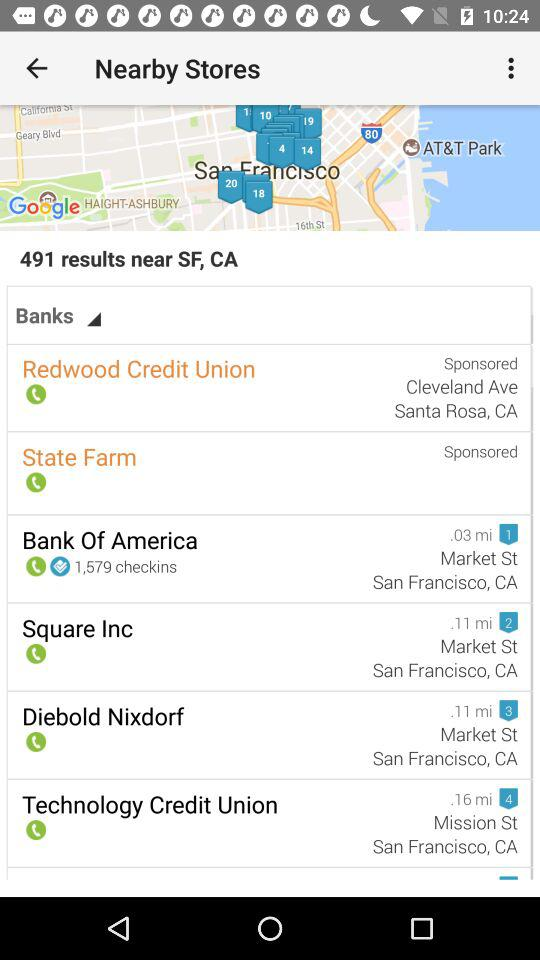What is the address of Square Inc? Square Inc's address is Market St., San Francisco, CA. 